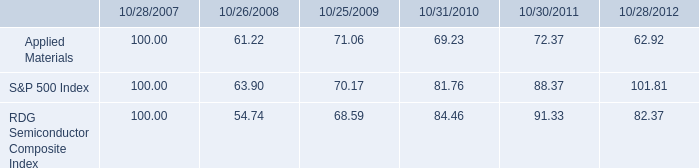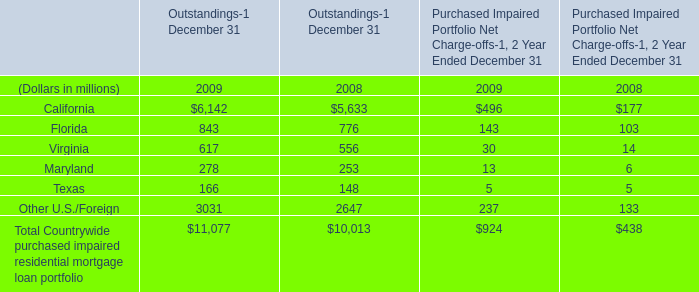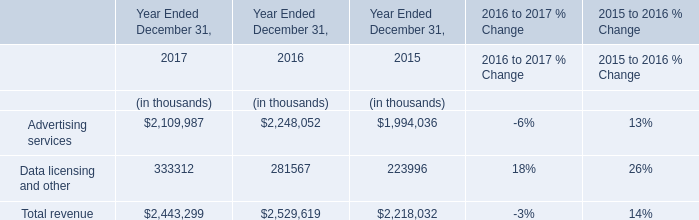What's the difference of Total Countrywide purchased impaired residential mortgage loan portfolio between 2009 and 2008? (in million) 
Computations: (11077 - 10013)
Answer: 1064.0. 